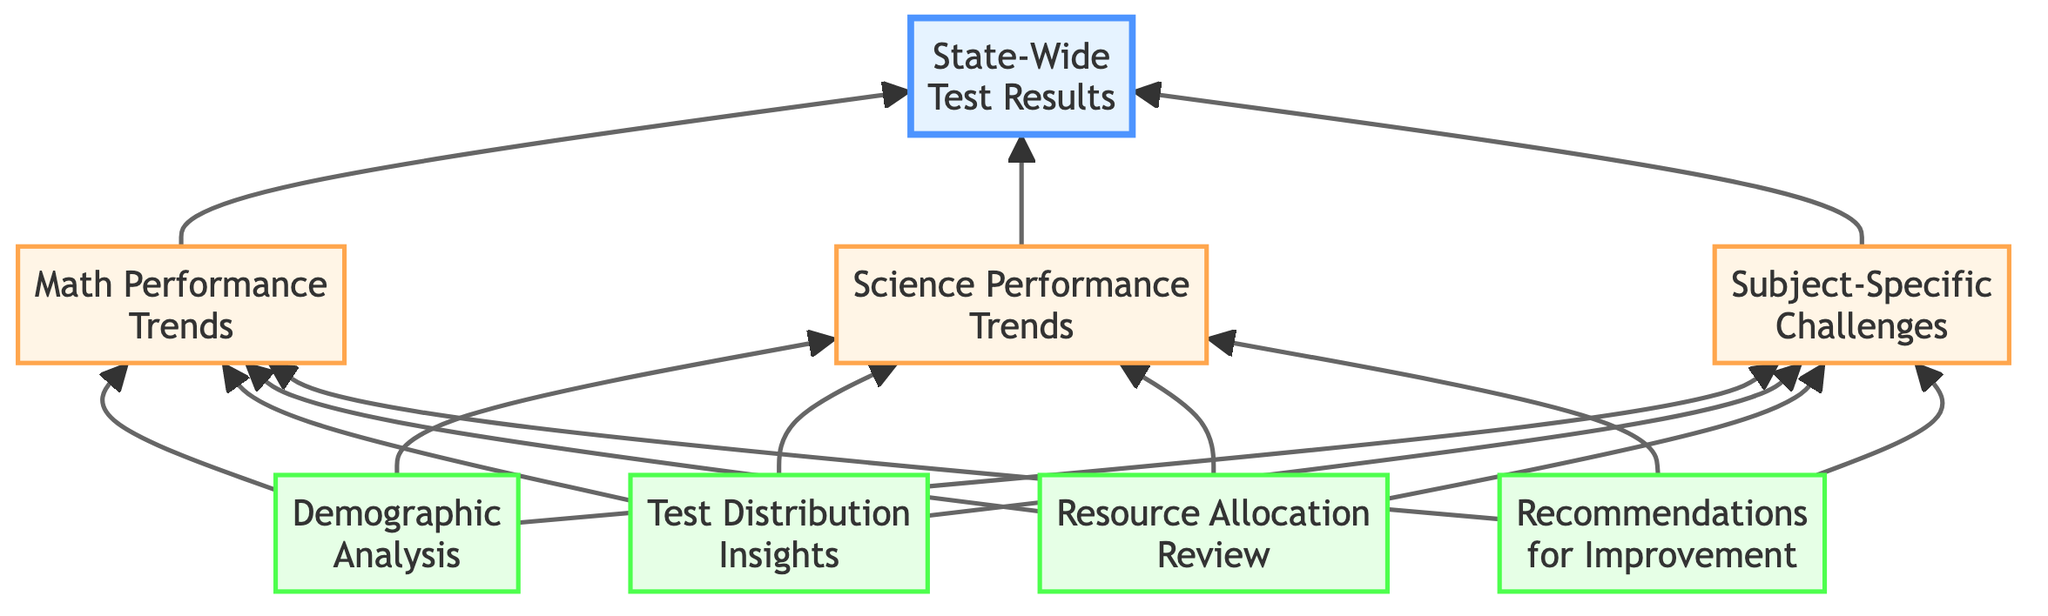What is the root element of the flow chart? The root element is the highest level in the diagram, which is indicated as "State-Wide Test Results."
Answer: State-Wide Test Results How many level 1 nodes are present in the diagram? Counting the nodes directly connected to the root element, there are three level 1 nodes: Math Performance Trends, Science Performance Trends, and Subject-Specific Challenges.
Answer: 3 What connects to the "Demographic Analysis" node? The "Demographic Analysis" node is connected to all three level 1 nodes: Math Performance Trends, Science Performance Trends, and Subject-Specific Challenges.
Answer: Math, Science, Subject Which node addresses funding related to math and science education? The node that specifically reviews funding is "Resource Allocation Review."
Answer: Resource Allocation Review What is the last node in the flow chart? The last node, which represents strategies for improvement after identifying problems, is "Recommendations for Improvement."
Answer: Recommendations for Improvement Which node specifically highlights strengths and weaknesses in science? "Science Performance Trends" is the node that evaluates standardized test scores in science, indicating strengths in biology and weaknesses in physics.
Answer: Science Performance Trends Which nodes feed information into the "Subject-Specific Challenges" node? The "Subject-Specific Challenges" node receives information from the three level 1 nodes: Math Performance Trends, Science Performance Trends, and Subject-Specific Challenges themselves.
Answer: Math, Science, Subject How many nodes are there in total in the diagram? To find the total number of nodes, count the root node, the three level 1 nodes, and the four level 2 nodes, giving us a total of eight nodes.
Answer: 8 What aspect does the "Test Distribution Insights" node analyze? The "Test Distribution Insights" focuses on the distribution of students across different performance levels, ranging from proficient to below basic.
Answer: Student performance levels 